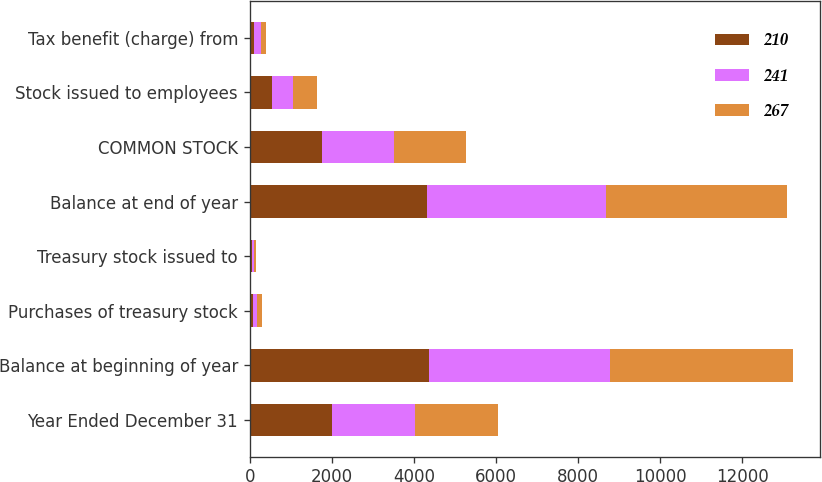Convert chart to OTSL. <chart><loc_0><loc_0><loc_500><loc_500><stacked_bar_chart><ecel><fcel>Year Ended December 31<fcel>Balance at beginning of year<fcel>Purchases of treasury stock<fcel>Treasury stock issued to<fcel>Balance at end of year<fcel>COMMON STOCK<fcel>Stock issued to employees<fcel>Tax benefit (charge) from<nl><fcel>210<fcel>2015<fcel>4366<fcel>86<fcel>44<fcel>4324<fcel>1760<fcel>532<fcel>94<nl><fcel>241<fcel>2014<fcel>4402<fcel>98<fcel>62<fcel>4366<fcel>1760<fcel>526<fcel>169<nl><fcel>267<fcel>2013<fcel>4469<fcel>121<fcel>54<fcel>4402<fcel>1760<fcel>569<fcel>144<nl></chart> 